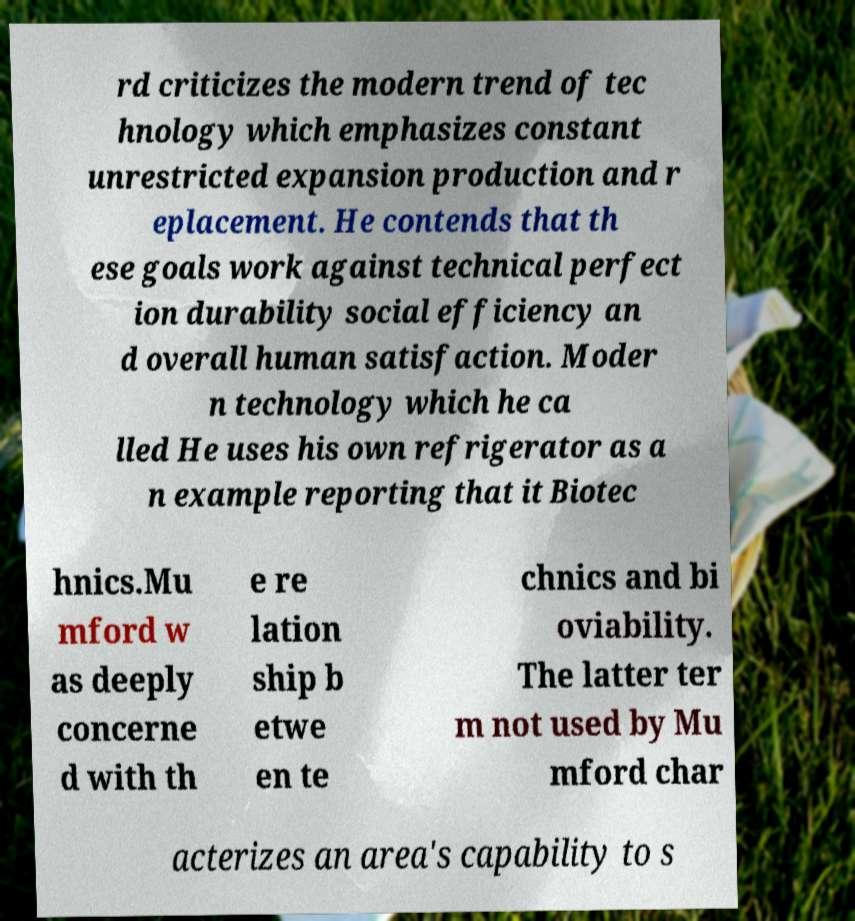Can you accurately transcribe the text from the provided image for me? rd criticizes the modern trend of tec hnology which emphasizes constant unrestricted expansion production and r eplacement. He contends that th ese goals work against technical perfect ion durability social efficiency an d overall human satisfaction. Moder n technology which he ca lled He uses his own refrigerator as a n example reporting that it Biotec hnics.Mu mford w as deeply concerne d with th e re lation ship b etwe en te chnics and bi oviability. The latter ter m not used by Mu mford char acterizes an area's capability to s 